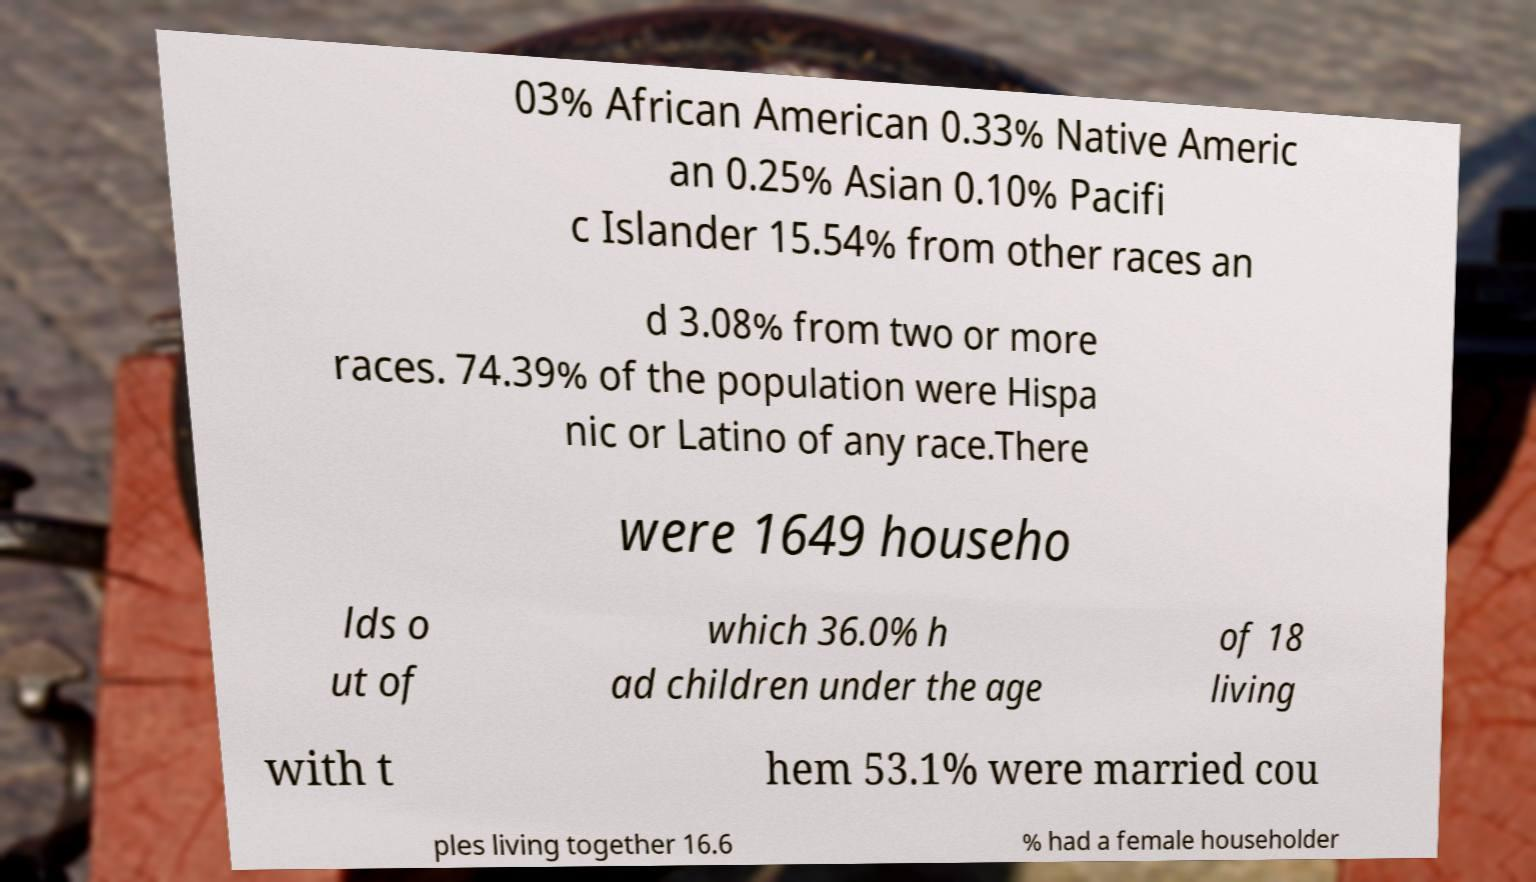I need the written content from this picture converted into text. Can you do that? 03% African American 0.33% Native Americ an 0.25% Asian 0.10% Pacifi c Islander 15.54% from other races an d 3.08% from two or more races. 74.39% of the population were Hispa nic or Latino of any race.There were 1649 househo lds o ut of which 36.0% h ad children under the age of 18 living with t hem 53.1% were married cou ples living together 16.6 % had a female householder 